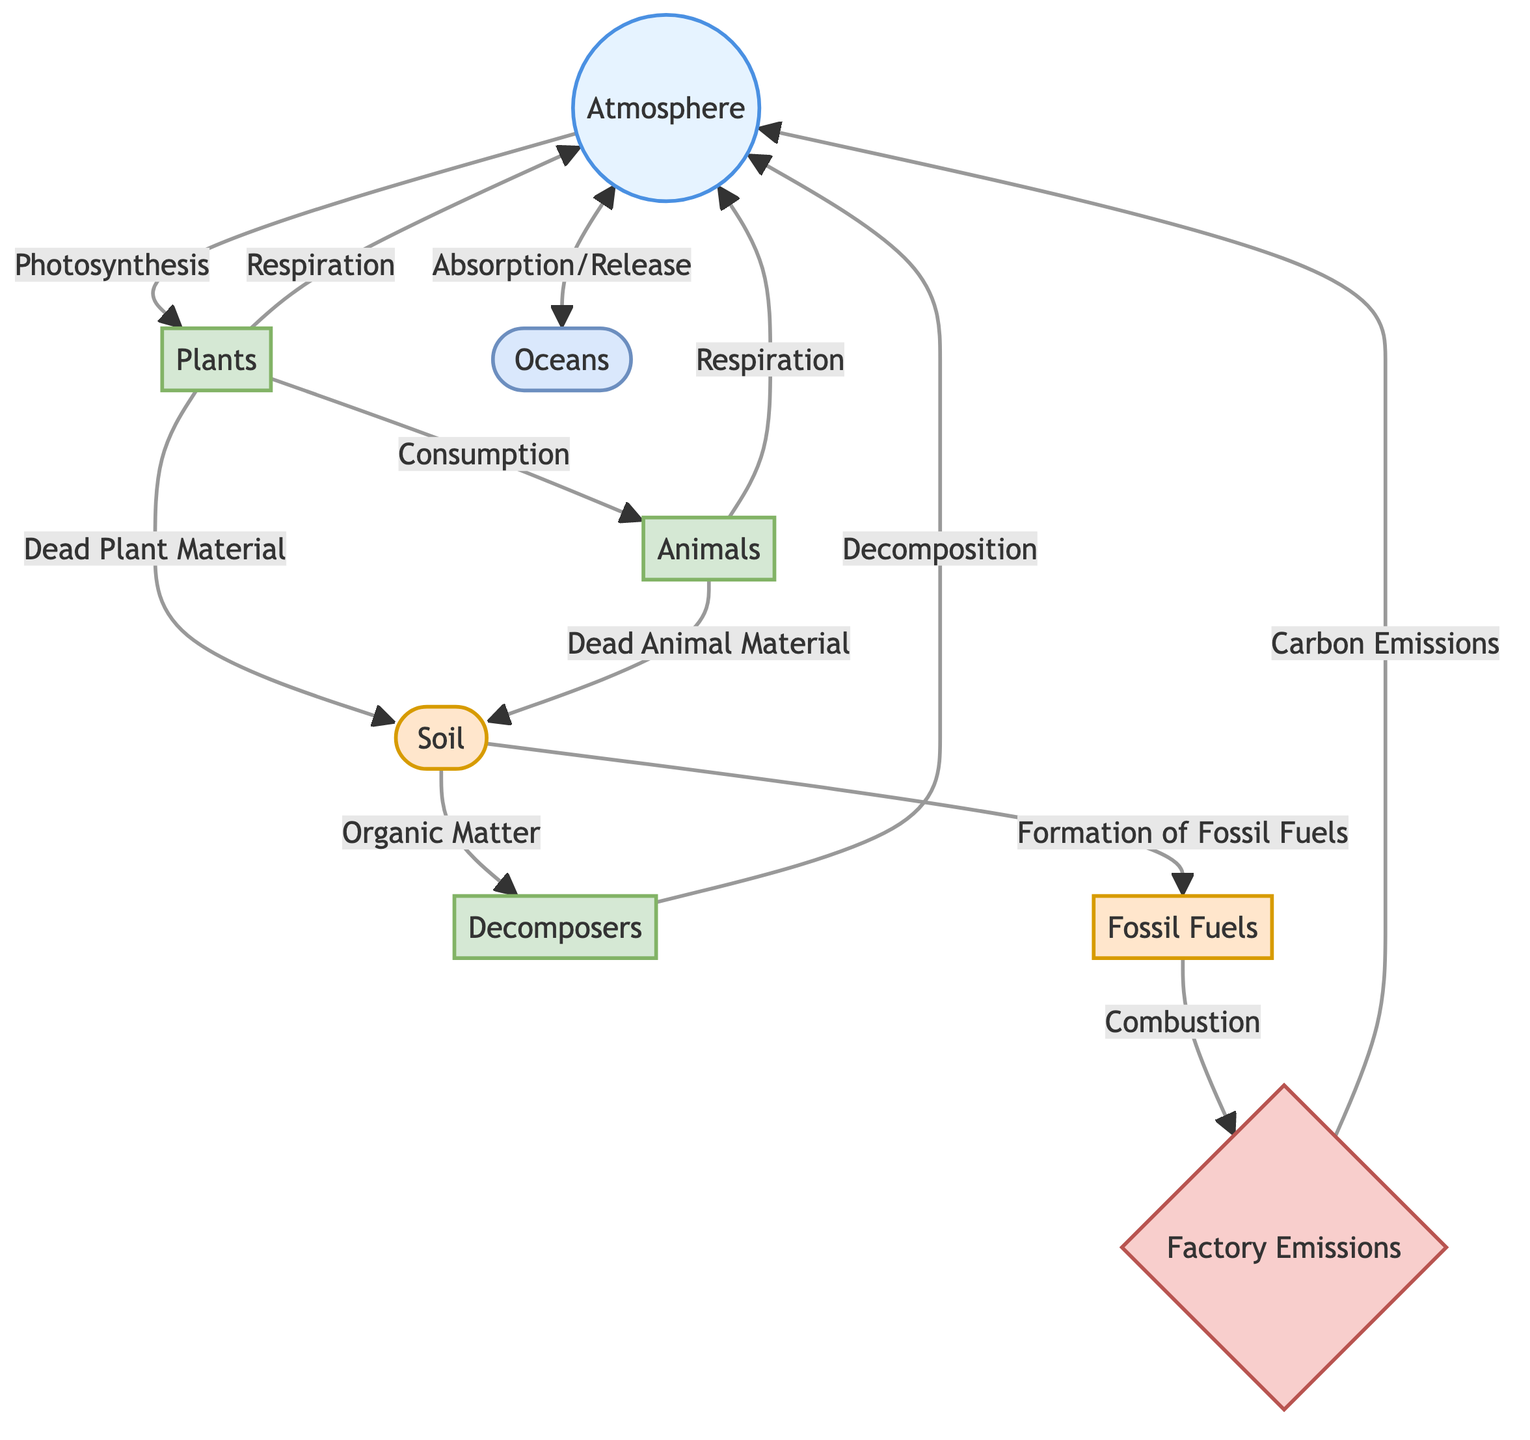What process do plants use to absorb carbon from the atmosphere? The diagram shows an arrow labeled "Photosynthesis" pointing from the "Atmosphere" node to the "Plants" node, indicating that through photosynthesis, plants absorb carbon dioxide from the atmosphere.
Answer: Photosynthesis How do animals obtain carbon in the carbon cycle? The diagram illustrates an arrow labeled "Consumption" from "Plants" to "Animals," which indicates that animals obtain carbon by consuming plants.
Answer: Consumption What process releases carbon back into the atmosphere from animals? The arrows labeled "Respiration" point from "Animals" and "Plants" to "Atmosphere," indicating that respiration is the process through which both plants and animals release carbon back into the atmosphere.
Answer: Respiration Which node represents the major source of carbon emissions in the diagram? The "Factory Emissions" node is highlighted with a distinct style and has lines connecting it to "Atmosphere," signaling that it is the source of carbon emissions resulting from combustion processes.
Answer: Factory Emissions How many processes are directly linked to the "Soil" node in the diagram? The node labeled "Soil" has three arrows descending from it, showing that the soil is involved in processes that contribute to organic matter decomposition, fossil fuel formation, and the activity of decomposers. Thus, it has a total of three processes.
Answer: 3 What happens to dead plant material according to the diagram? From the "Plants" node, there is an arrow labeled "Dead Plant Material" that directs into the "Soil" node, indicating that dead plant material contributes to soil composition.
Answer: Contributes to Soil Which component absorbs or releases carbon from the atmosphere? The "Oceans" node reflects a bidirectional arrow labeled "Absorption/Release," indicating that oceans play a critical role in both absorbing and releasing carbon dioxide.
Answer: Oceans What role do decomposers play in the carbon cycle according to the diagram? The diagram shows arrow labels "Decomposition" directing from "Decomposers" to "Atmosphere," indicating that decomposers are responsible for breaking down organic matter and releasing carbon back into the atmosphere.
Answer: Release Carbon How are fossil fuels created in the carbon cycle? The diagram illustrates that "Soil" contributes to the "Formation of Fossil Fuels" via an arrow pointing to "Fossil Fuels," indicating that decomposed organic matter over time can become fossil fuels.
Answer: Formation of Fossil Fuels 